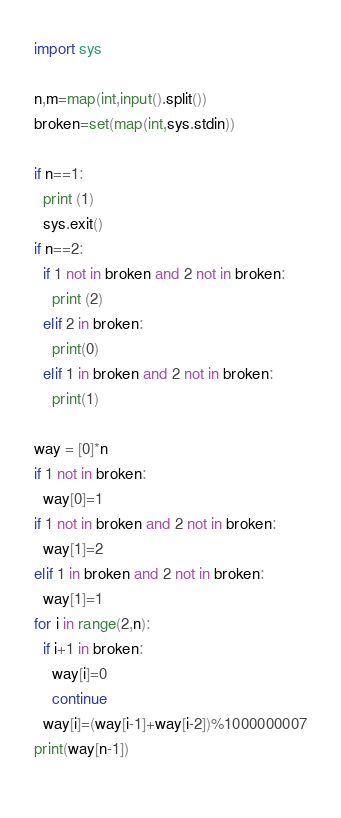Convert code to text. <code><loc_0><loc_0><loc_500><loc_500><_Python_>import sys

n,m=map(int,input().split())
broken=set(map(int,sys.stdin))

if n==1:
  print (1)
  sys.exit()
if n==2:
  if 1 not in broken and 2 not in broken:
    print (2)
  elif 2 in broken:
    print(0)
  elif 1 in broken and 2 not in broken:
    print(1)

way = [0]*n
if 1 not in broken:
  way[0]=1
if 1 not in broken and 2 not in broken:
  way[1]=2
elif 1 in broken and 2 not in broken:
  way[1]=1
for i in range(2,n):
  if i+1 in broken:
    way[i]=0
    continue
  way[i]=(way[i-1]+way[i-2])%1000000007
print(way[n-1])
  </code> 